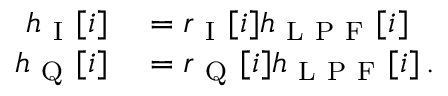Convert formula to latex. <formula><loc_0><loc_0><loc_500><loc_500>\begin{array} { r l } { h _ { I } [ i ] } & = r _ { I } [ i ] h _ { L P F } [ i ] } \\ { h _ { Q } [ i ] } & = r _ { Q } [ i ] h _ { L P F } [ i ] \, . } \end{array}</formula> 